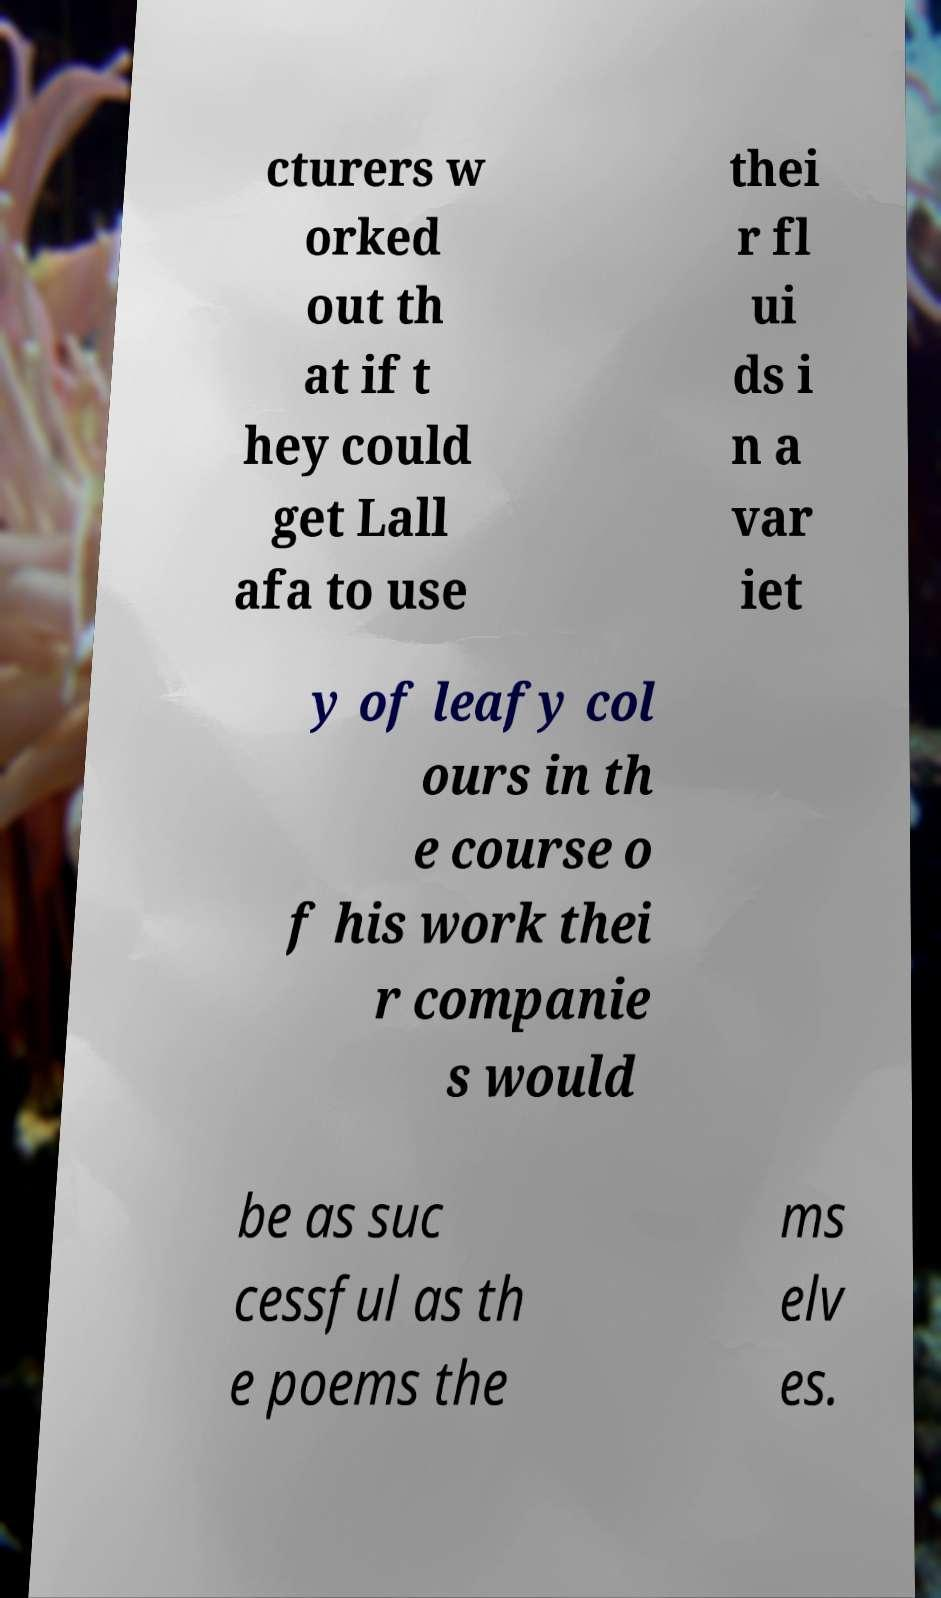There's text embedded in this image that I need extracted. Can you transcribe it verbatim? cturers w orked out th at if t hey could get Lall afa to use thei r fl ui ds i n a var iet y of leafy col ours in th e course o f his work thei r companie s would be as suc cessful as th e poems the ms elv es. 